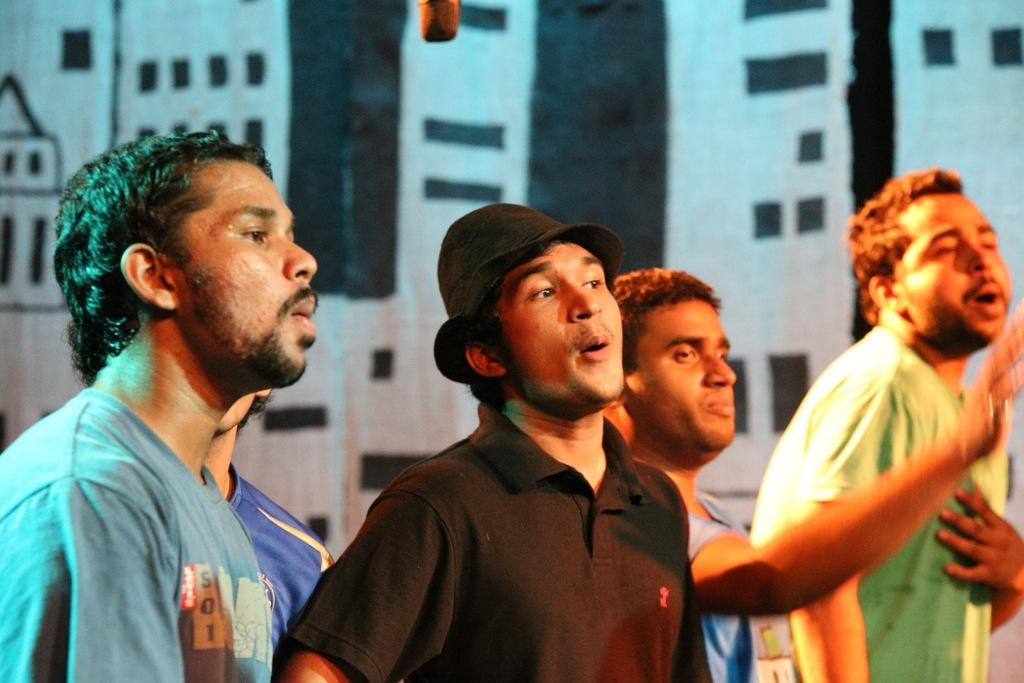How many people are in the image? There is a group of people standing in the image. What can be seen in the background of the image? There is a painting on the wall in the background of the image. Can you describe the object visible at the top of the image? Unfortunately, the facts provided do not give enough information to describe the object visible at the top of the image. What type of glove is being smashed by the tomatoes in the image? There is no glove or tomatoes present in the image. 